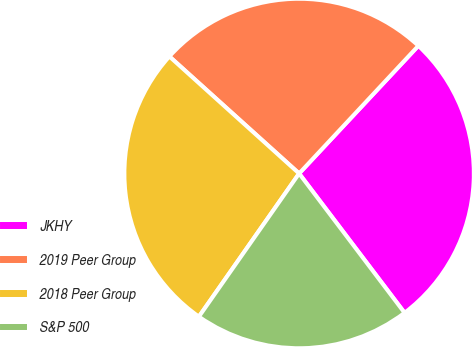Convert chart. <chart><loc_0><loc_0><loc_500><loc_500><pie_chart><fcel>JKHY<fcel>2019 Peer Group<fcel>2018 Peer Group<fcel>S&P 500<nl><fcel>27.73%<fcel>25.27%<fcel>26.96%<fcel>20.03%<nl></chart> 